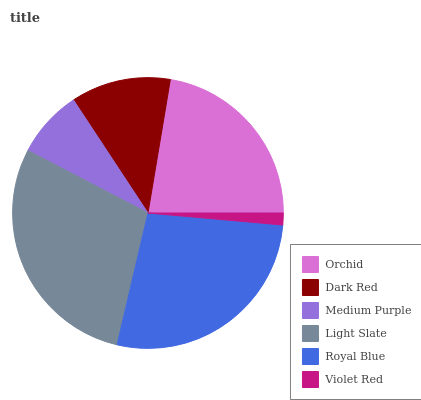Is Violet Red the minimum?
Answer yes or no. Yes. Is Light Slate the maximum?
Answer yes or no. Yes. Is Dark Red the minimum?
Answer yes or no. No. Is Dark Red the maximum?
Answer yes or no. No. Is Orchid greater than Dark Red?
Answer yes or no. Yes. Is Dark Red less than Orchid?
Answer yes or no. Yes. Is Dark Red greater than Orchid?
Answer yes or no. No. Is Orchid less than Dark Red?
Answer yes or no. No. Is Orchid the high median?
Answer yes or no. Yes. Is Dark Red the low median?
Answer yes or no. Yes. Is Light Slate the high median?
Answer yes or no. No. Is Orchid the low median?
Answer yes or no. No. 